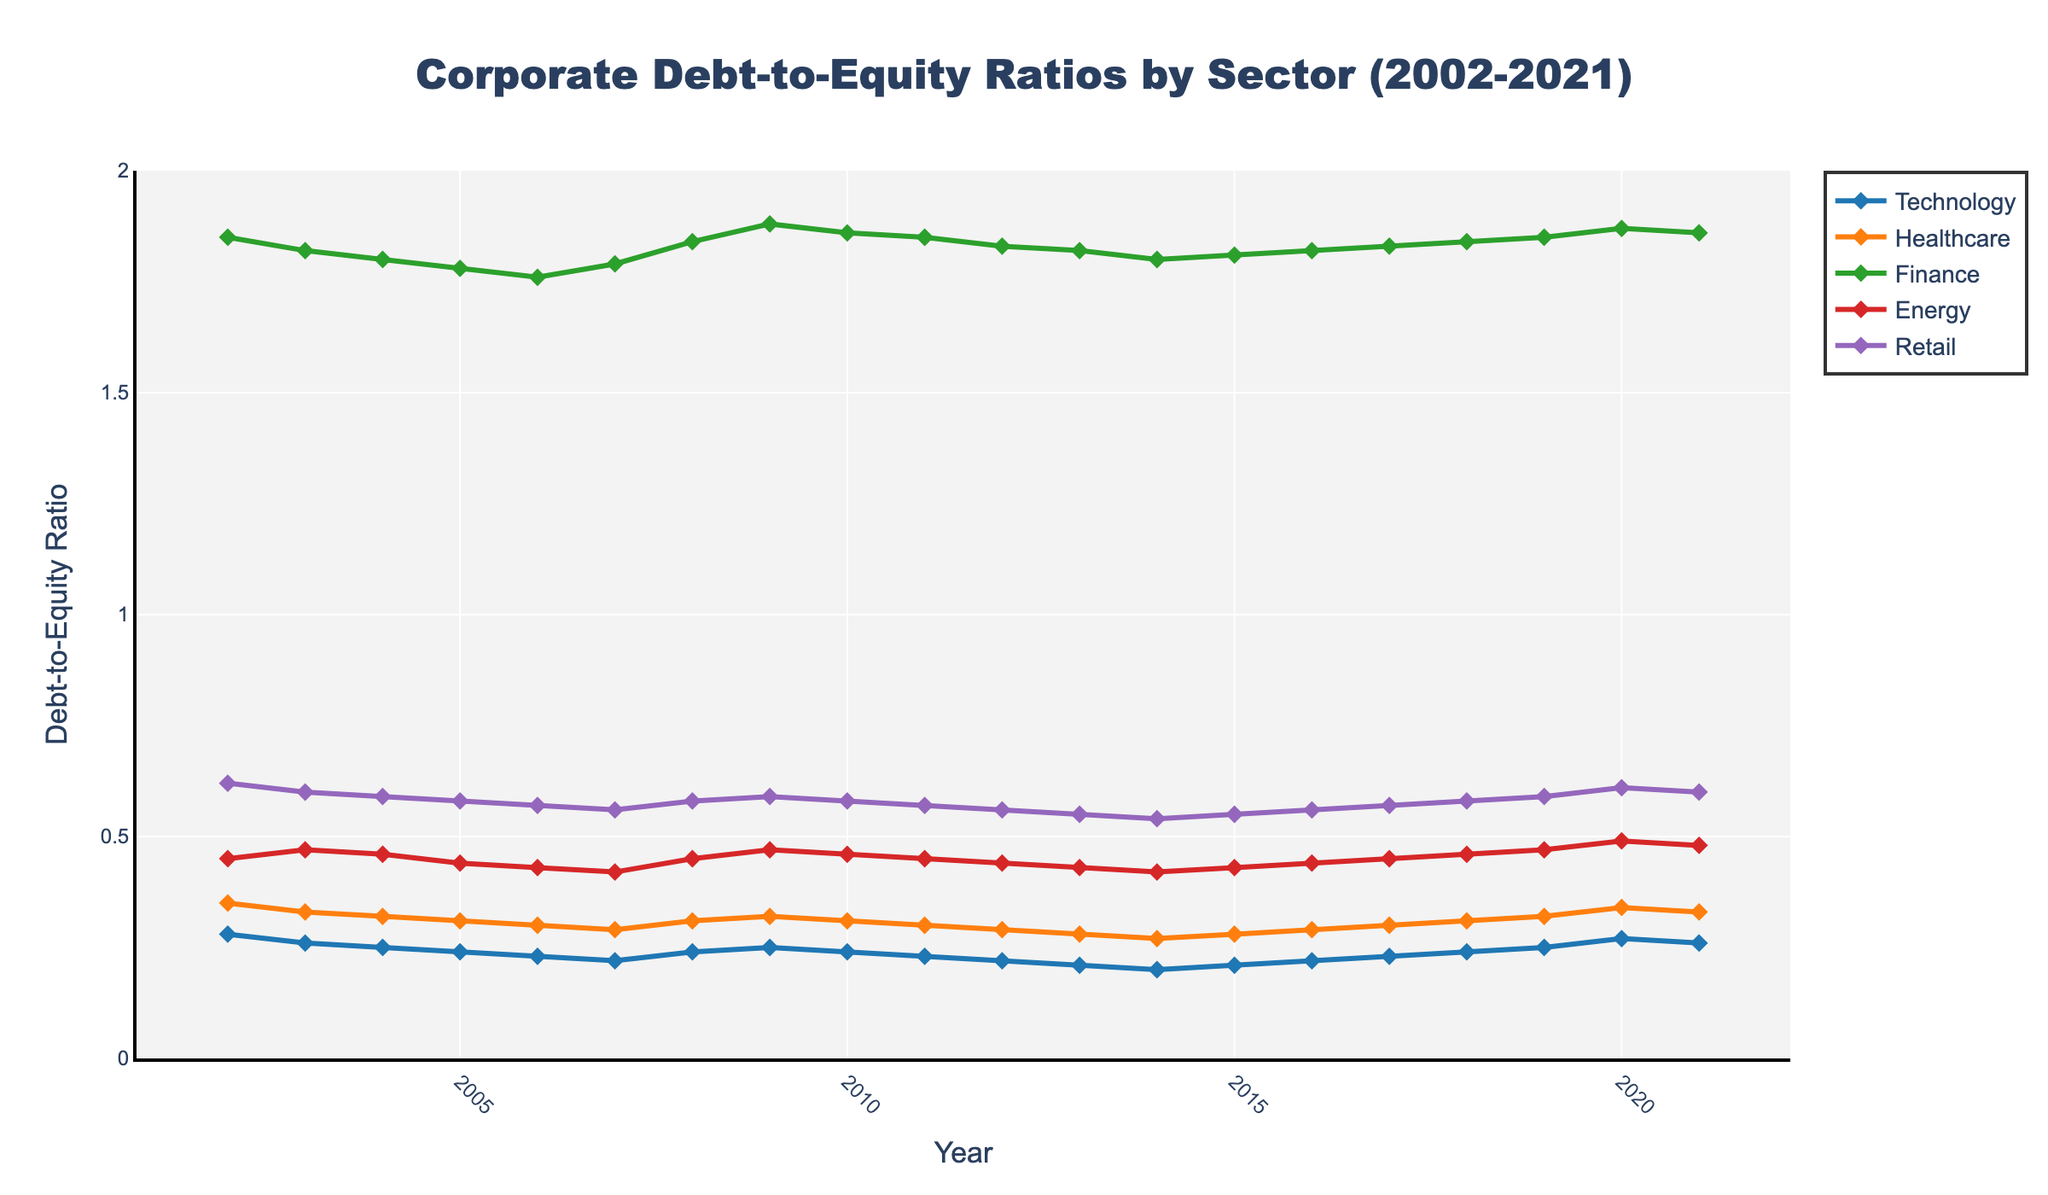What is the overall trend of the Technology sector's debt-to-equity ratio from 2002 to 2021? The line representing the Technology sector in the chart shows a decreasing trend from 2002 to 2014, followed by a slight increase from 2015 onwards.
Answer: Decreasing then slightly increasing Which sector had the highest debt-to-equity ratio in 2021, and what was its value? Observing the y-axis values and the corresponding lines, the Finance sector had the highest debt-to-equity ratio in 2021.
Answer: Finance, 1.86 How did the debt-to-equity ratio for the Energy sector change between 2002 and 2021? Looking at the plot, the line for the Energy sector shows a slight increase from 0.45 in 2002 to 0.48 in 2021. The increase is relatively small.
Answer: Slight increase Which year had the lowest debt-to-equity ratio for the Retail sector, and what was the value? By tracing the Retail sector's line, the lowest ratio occurs in 2014 with a value of 0.54.
Answer: 2014, 0.54 Compare the debt-to-equity ratios of Technology and Healthcare sectors in 2010. Which sector had a lower ratio, and by how much? In 2010, the Technology sector had a ratio of 0.24, and the Healthcare sector had 0.31. The Technology sector's ratio was lower by 0.07.
Answer: Technology, 0.07 Which sector showed the most significant volatility in debt-to-equity ratio over the 20-year period? By examining the ups and downs in the plot, the Finance sector shows the most significant volatility, with large fluctuations between years.
Answer: Finance In which year did the Energy sector's debt-to-equity ratio peak, and what was its value? Looking at the line for the Energy sector, it peaked in 2020 with a value of 0.49.
Answer: 2020, 0.49 Calculate the average debt-to-equity ratio for the Healthcare sector from 2002 to 2021. Summing up the values for each year (0.35 + 0.33 + 0.32 + 0.31 + 0.30 + 0.29 + 0.31 + 0.32 + 0.31 + 0.30 + 0.29 + 0.28 + 0.27 + 0.28 + 0.29 + 0.30 + 0.31 + 0.32 + 0.34 + 0.33) and dividing by 20 (number of data points) = 6.33 / 20 = 0.3165.
Answer: 0.3165 Identify any two sectors that had the same debt-to-equity ratio at any given year and specify the ratio and the year. In 2010, both Finance and Energy sectors had a debt-to-equity ratio of 0.46.
Answer: Finance and Energy, 0.46, 2010 